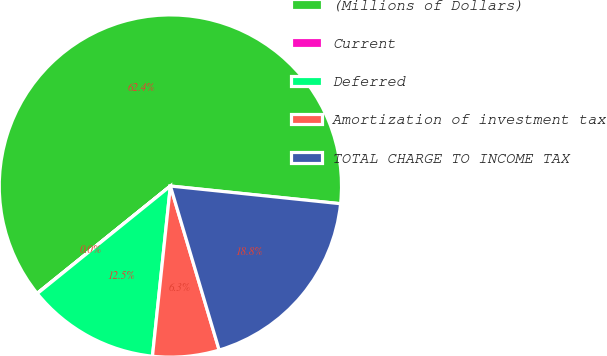Convert chart. <chart><loc_0><loc_0><loc_500><loc_500><pie_chart><fcel>(Millions of Dollars)<fcel>Current<fcel>Deferred<fcel>Amortization of investment tax<fcel>TOTAL CHARGE TO INCOME TAX<nl><fcel>62.43%<fcel>0.03%<fcel>12.51%<fcel>6.27%<fcel>18.75%<nl></chart> 